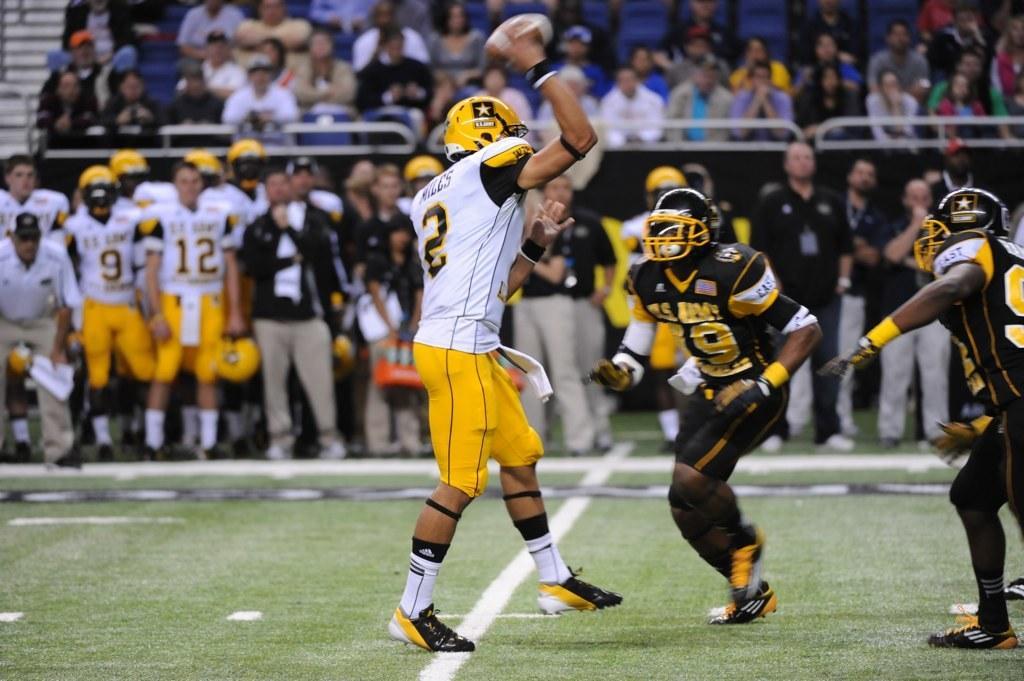In one or two sentences, can you explain what this image depicts? There are groups of people standing and few people sitting on the chairs. This person is holding the kind of a ball in his hand. I think this is the ground. 